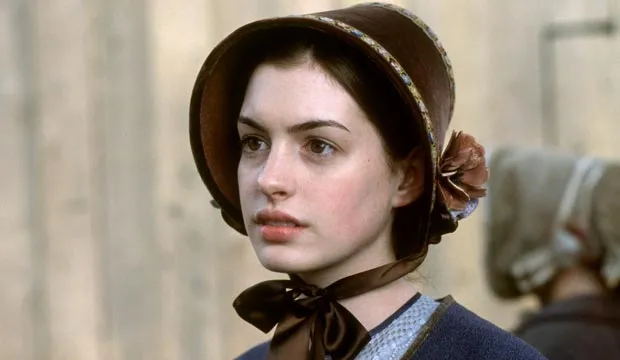What do you think is going on in this snapshot? This image captures a woman dressed in an early 19th-century costume, suggesting she might be portraying a character from that era. Her attire consists of a blue dress with a brown bonnet, and a black ribbon tied around her neck, typical of the fashion in historical dramas. The serious expression on her face and her contemplative gaze directed to the side add a narrative depth, indicating she might be in a moment of introspection or facing a challenging situation. The blurred background with another figure hints at a public or perhaps a bustling setting, possibly aligning with a scene involving social interaction or public engagement in the storyline. 